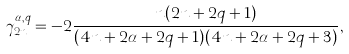<formula> <loc_0><loc_0><loc_500><loc_500>\gamma _ { 2 n } ^ { \alpha , q } = - 2 \frac { n ( 2 n + 2 q + 1 ) } { ( 4 n + 2 \alpha + 2 q + 1 ) ( 4 n + 2 \alpha + 2 q + 3 ) } ,</formula> 